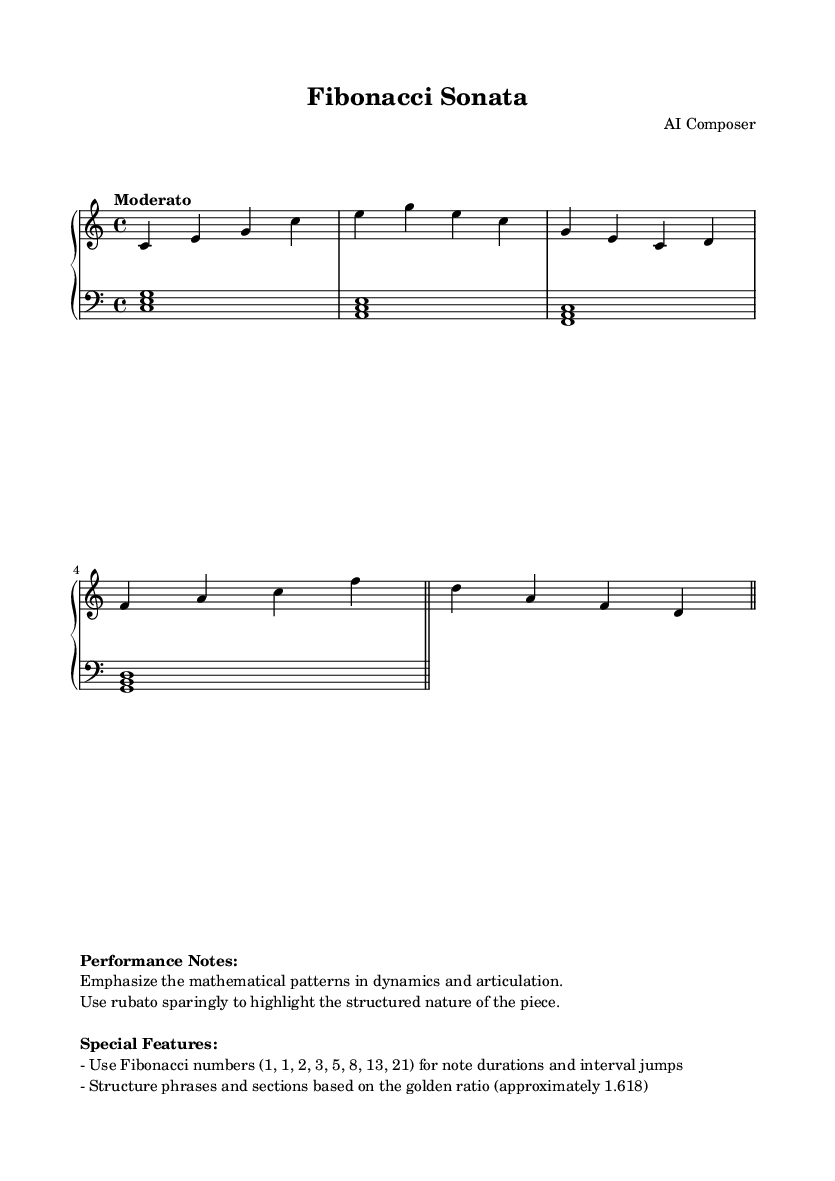What is the key signature of this music? The key signature is indicated at the beginning of the music piece and shows no sharps or flats, which corresponds to C major.
Answer: C major What is the time signature of this piece? The time signature is written at the start of the piece; it appears as 4/4, meaning there are four beats per measure.
Answer: 4/4 What is the tempo marking? The tempo marking can be found at the beginning, indicating the desired speed of the piece, which is "Moderato."
Answer: Moderato How many measures are there in this piece? By counting the horizontal lines between the bar lines in the sheet music, we can determine the total number of measures, which is four.
Answer: Four What mathematical sequence is used for note durations in this piece? The piece emphasizes Fibonacci numbers for structuring, as mentioned in the performance notes; the first few numbers of this sequence are typically listed.
Answer: Fibonacci What is the structure that phrases and sections are based on? The performance notes describe that phrases and sections are structured according to the golden ratio, which is approximately 1.618.
Answer: Golden ratio In which clef is the left hand written? The left hand is indicated in the bass part of the staff; this is visibly marked by the clef symbol at the beginning of that staff.
Answer: Bass 